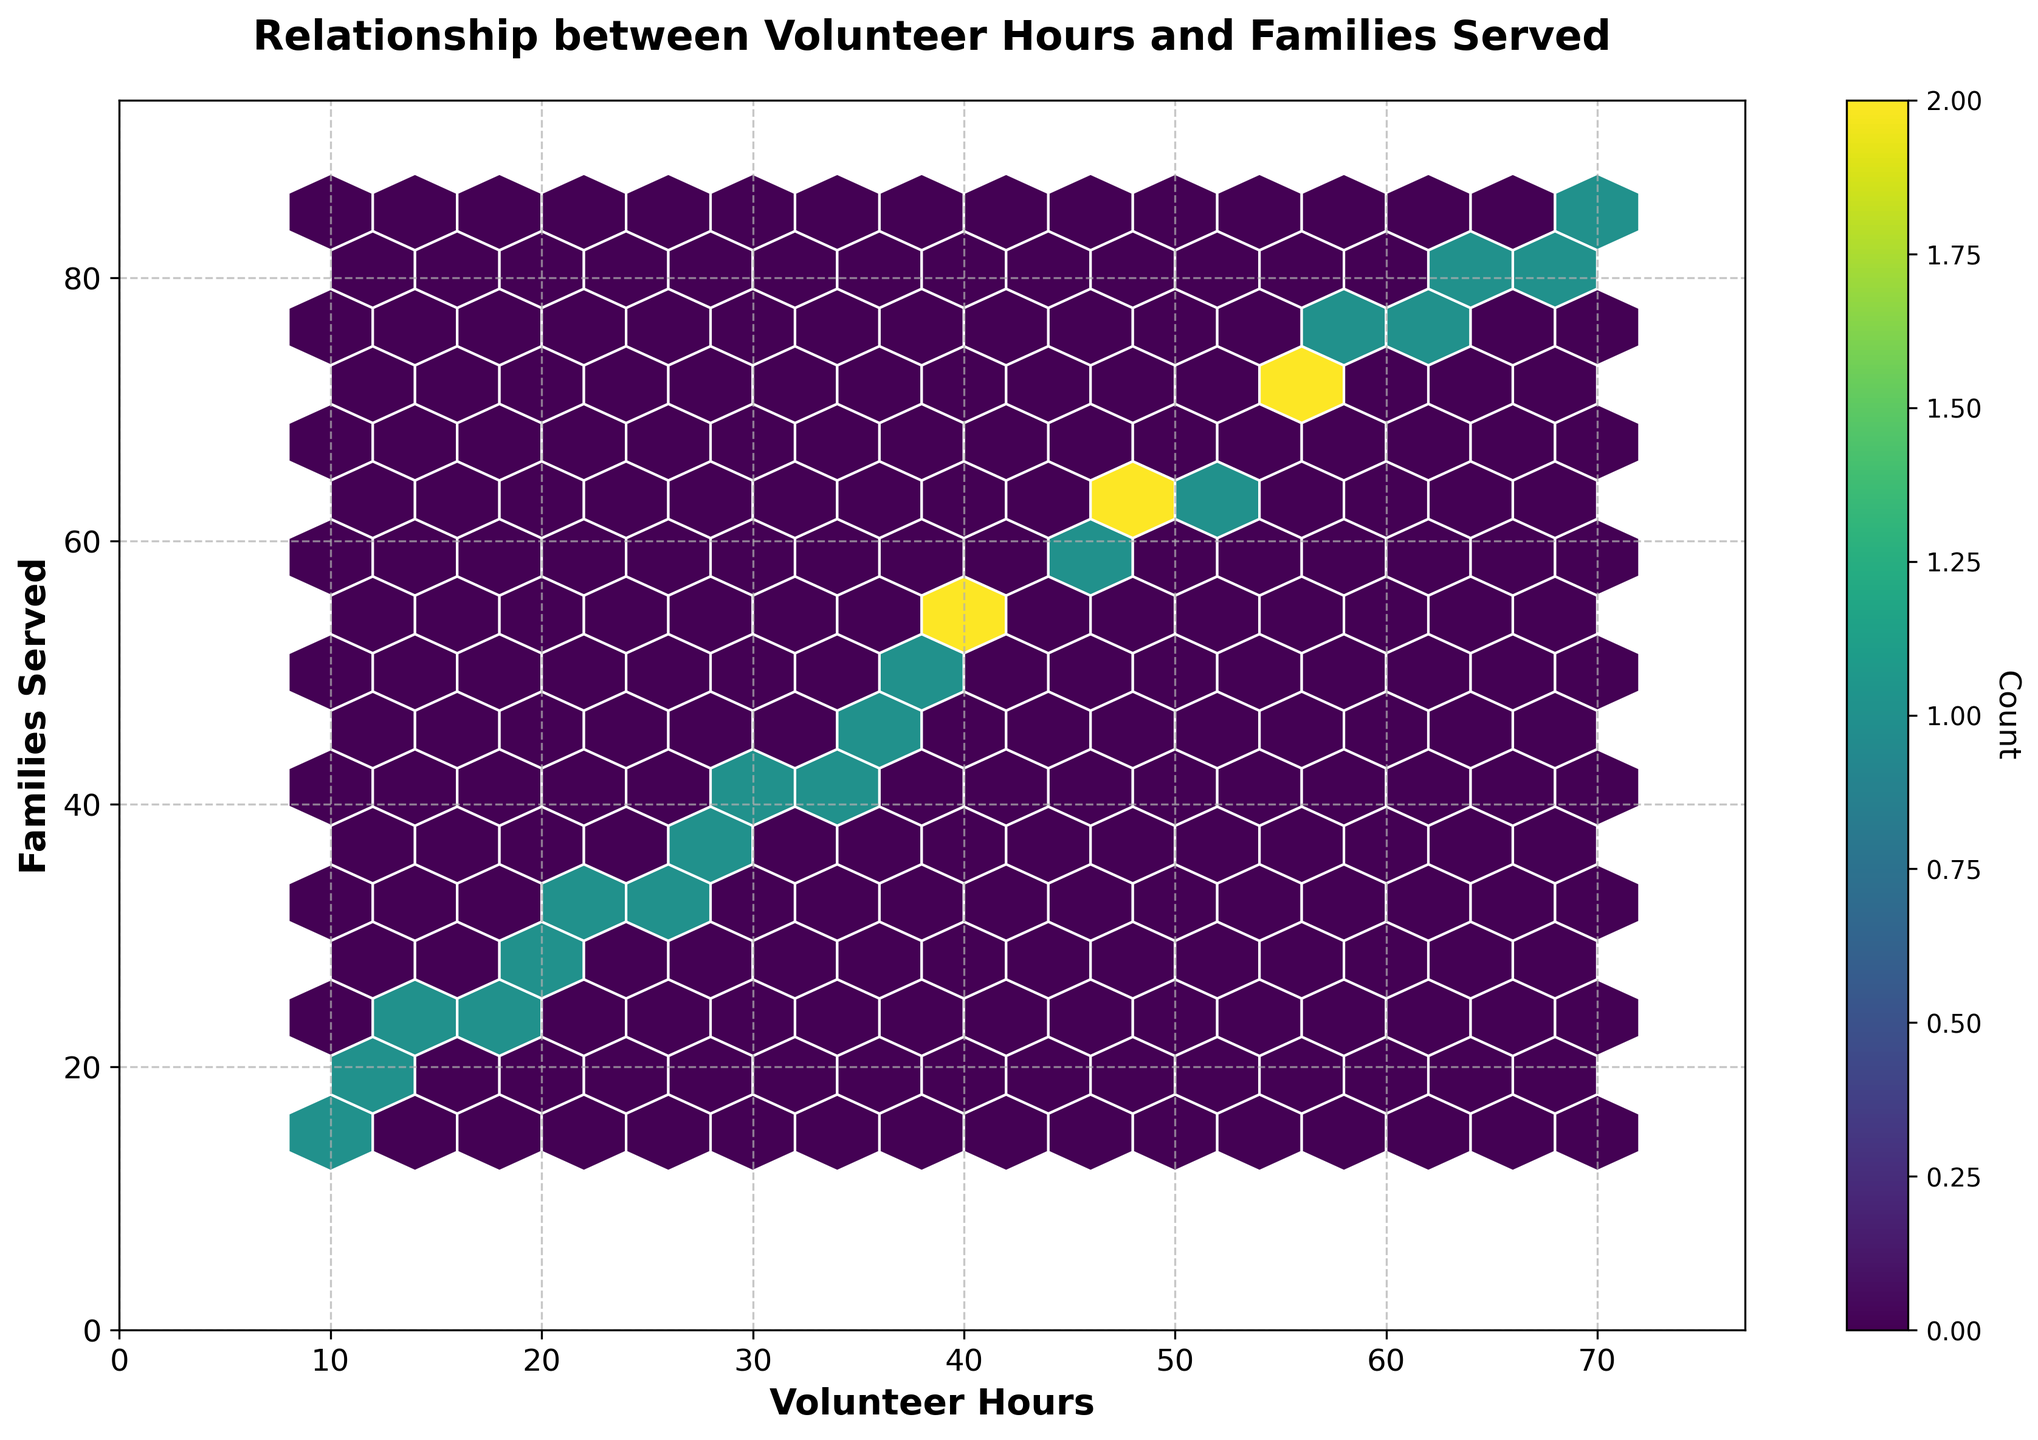What is the title of the figure? The title can be found at the top of the figure where it generally provides a summary of what the plot is about.
Answer: Relationship between Volunteer Hours and Families Served What are the labels of the X and Y axes? The labels are positioned along the respective axes and denote what each axis represents in the plot.
Answer: Volunteer Hours and Families Served How many bins are displayed along the X-axis? To determine the number of bins, we need to count the distinct hexagon columns along the X-axis. These represent the divisions for volunteer hours.
Answer: 15 What is the maximum range of Volunteer Hours shown on the X-axis? The X-axis range can be determined by looking at the maximum value displayed in the plot plus any buffer added to extend it.
Answer: Approximately 77 Which hexagon has the highest count and where is it located? The color intensity of the hexagons represents the count. The hexagon with the deepest color and its position along the axes gives this answer.
Answer: The hexagon around (50, 64) has the highest count Is there a visible trend in the relationship between volunteer hours and families served? By observing the pattern of hexagon density, we can infer if there's a consistent relationship between the two variables.
Answer: Yes, there is a positive correlation What can you infer about the relationship if the hexagons are concentrated along a diagonal line? A diagonal concentration usually indicates a direct proportional or linear relationship, where one variable increases as the other does.
Answer: There is a linear relationship Are there any outliers that do not fit the overall trend? Outliers can be identified by points that are isolated from the majority of the data.
Answer: No significant outliers What is the average number of families served when Volunteer Hours are around 40? Identify the hexagons around the 40-mark on the X-axis and estimate the average value on the Y-axis from their positions.
Answer: Approximately 52 families How does the color bar aid in interpreting the data on the plot? The color bar provides a scale that translates the color intensity of the hexagons to the count of points within each bin, aiding in understanding density.
Answer: It shows the count 